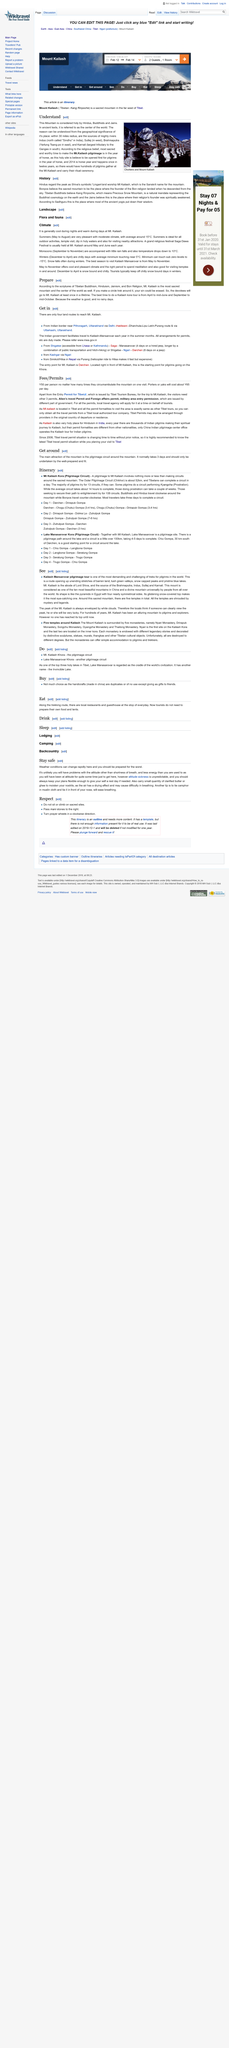Highlight a few significant elements in this photo. Karnali is the largest tributary to join the Ganges in the south. The year of the horse occurs every 12 years, The Mountain is venerated by Hindus, Buddhists, and Jains as a sacred entity. 